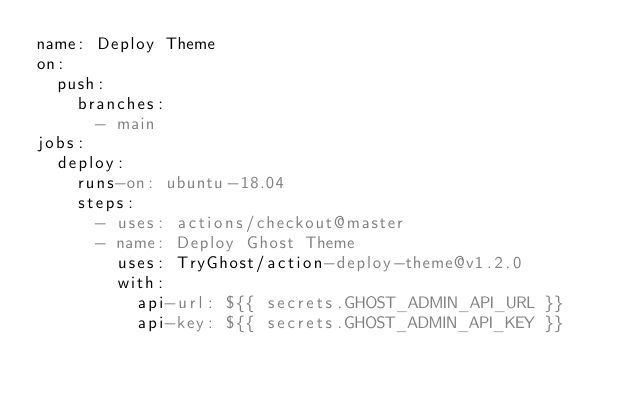<code> <loc_0><loc_0><loc_500><loc_500><_YAML_>name: Deploy Theme
on:
  push:	
    branches:	
      - main
jobs:
  deploy:
    runs-on: ubuntu-18.04
    steps:
      - uses: actions/checkout@master
      - name: Deploy Ghost Theme
        uses: TryGhost/action-deploy-theme@v1.2.0
        with:
          api-url: ${{ secrets.GHOST_ADMIN_API_URL }}
          api-key: ${{ secrets.GHOST_ADMIN_API_KEY }}
</code> 